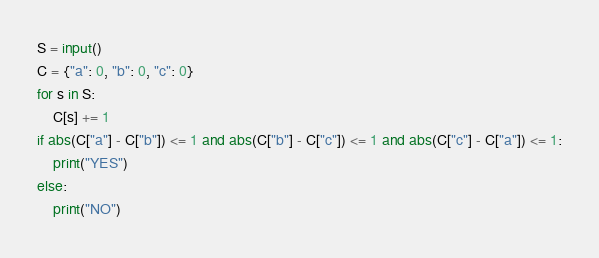<code> <loc_0><loc_0><loc_500><loc_500><_Python_>S = input()
C = {"a": 0, "b": 0, "c": 0}
for s in S:
    C[s] += 1
if abs(C["a"] - C["b"]) <= 1 and abs(C["b"] - C["c"]) <= 1 and abs(C["c"] - C["a"]) <= 1:
    print("YES")
else:
    print("NO")
</code> 